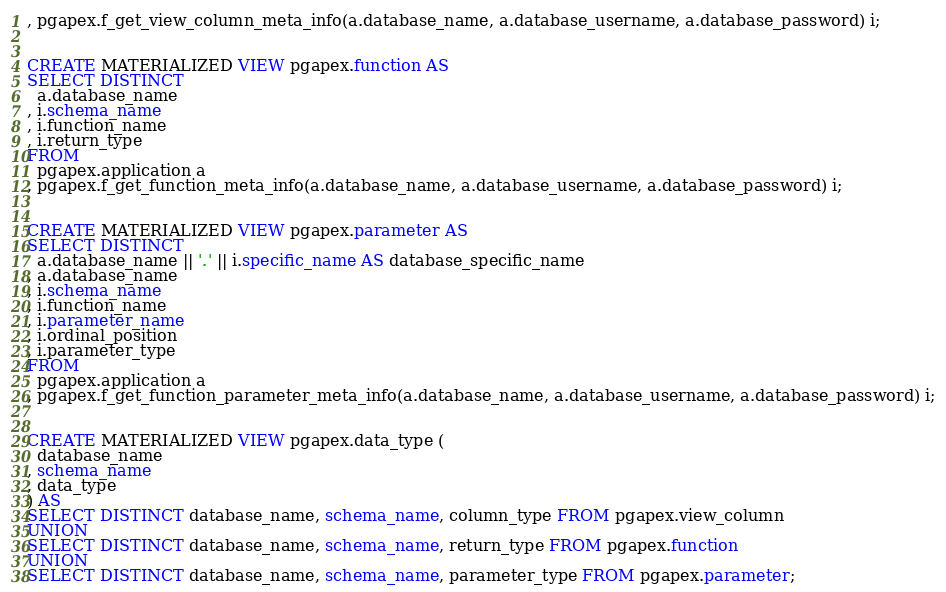<code> <loc_0><loc_0><loc_500><loc_500><_SQL_>, pgapex.f_get_view_column_meta_info(a.database_name, a.database_username, a.database_password) i;


CREATE MATERIALIZED VIEW pgapex.function AS
SELECT DISTINCT
  a.database_name
, i.schema_name
, i.function_name
, i.return_type
FROM
  pgapex.application a
, pgapex.f_get_function_meta_info(a.database_name, a.database_username, a.database_password) i;


CREATE MATERIALIZED VIEW pgapex.parameter AS
SELECT DISTINCT
  a.database_name || '.' || i.specific_name AS database_specific_name
, a.database_name
, i.schema_name
, i.function_name
, i.parameter_name
, i.ordinal_position
, i.parameter_type
FROM
  pgapex.application a
, pgapex.f_get_function_parameter_meta_info(a.database_name, a.database_username, a.database_password) i;


CREATE MATERIALIZED VIEW pgapex.data_type (
  database_name
, schema_name
, data_type
) AS
SELECT DISTINCT database_name, schema_name, column_type FROM pgapex.view_column
UNION
SELECT DISTINCT database_name, schema_name, return_type FROM pgapex.function
UNION
SELECT DISTINCT database_name, schema_name, parameter_type FROM pgapex.parameter;</code> 